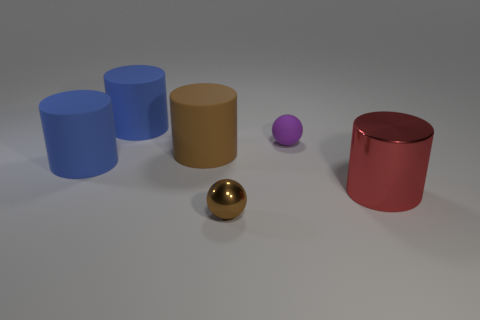Subtract all brown cylinders. How many cylinders are left? 3 Add 2 big yellow matte blocks. How many objects exist? 8 Subtract all purple balls. How many balls are left? 1 Subtract 1 spheres. How many spheres are left? 1 Add 2 big red metallic things. How many big red metallic things exist? 3 Subtract 0 yellow cubes. How many objects are left? 6 Subtract all spheres. How many objects are left? 4 Subtract all brown balls. Subtract all yellow cubes. How many balls are left? 1 Subtract all gray balls. How many blue cylinders are left? 2 Subtract all large blue cylinders. Subtract all matte objects. How many objects are left? 0 